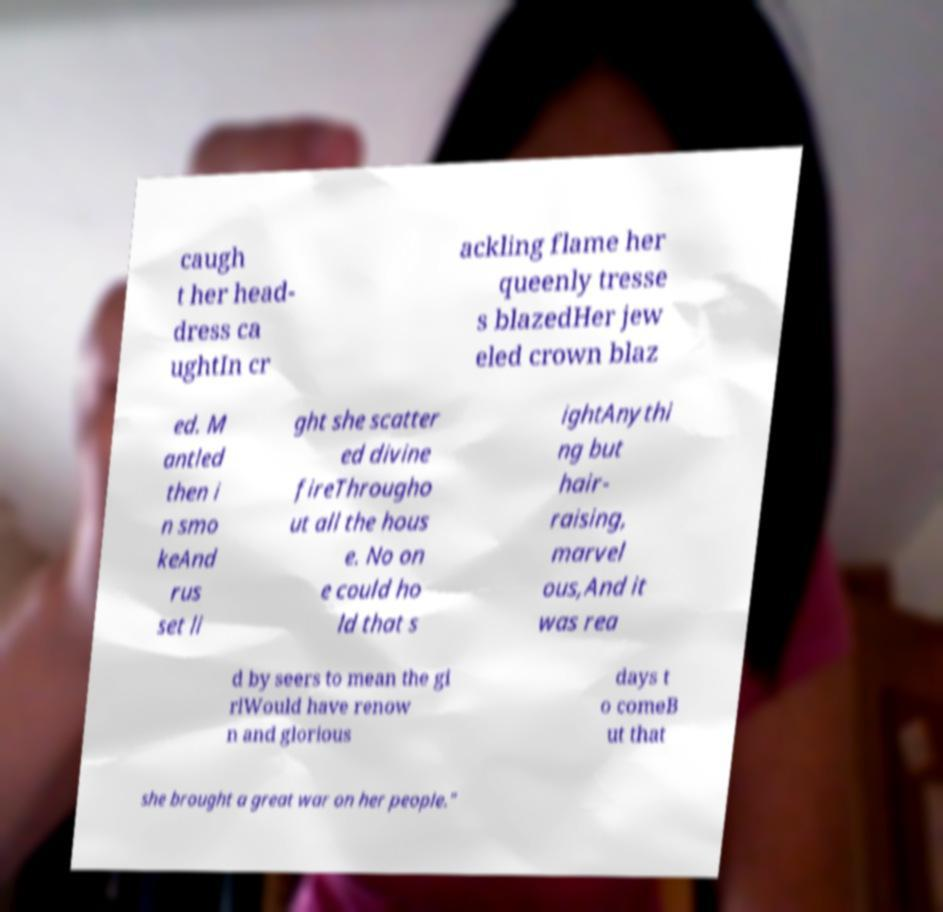Can you read and provide the text displayed in the image?This photo seems to have some interesting text. Can you extract and type it out for me? caugh t her head- dress ca ughtIn cr ackling flame her queenly tresse s blazedHer jew eled crown blaz ed. M antled then i n smo keAnd rus set li ght she scatter ed divine fireThrougho ut all the hous e. No on e could ho ld that s ightAnythi ng but hair- raising, marvel ous,And it was rea d by seers to mean the gi rlWould have renow n and glorious days t o comeB ut that she brought a great war on her people." 